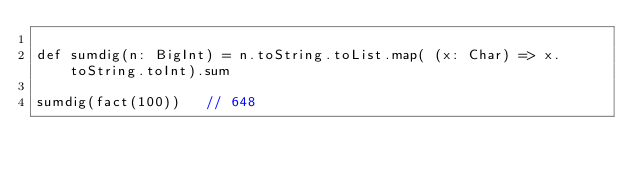<code> <loc_0><loc_0><loc_500><loc_500><_Scala_>
def sumdig(n: BigInt) = n.toString.toList.map( (x: Char) => x.toString.toInt).sum

sumdig(fact(100))   // 648</code> 